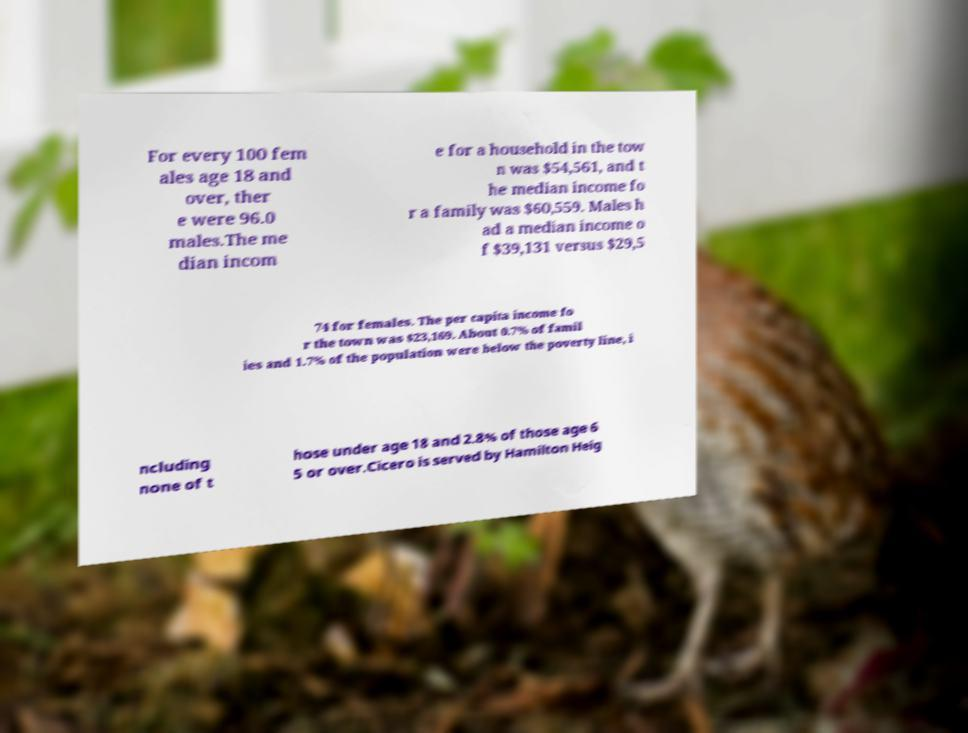Please read and relay the text visible in this image. What does it say? For every 100 fem ales age 18 and over, ther e were 96.0 males.The me dian incom e for a household in the tow n was $54,561, and t he median income fo r a family was $60,559. Males h ad a median income o f $39,131 versus $29,5 74 for females. The per capita income fo r the town was $23,169. About 0.7% of famil ies and 1.7% of the population were below the poverty line, i ncluding none of t hose under age 18 and 2.8% of those age 6 5 or over.Cicero is served by Hamilton Heig 